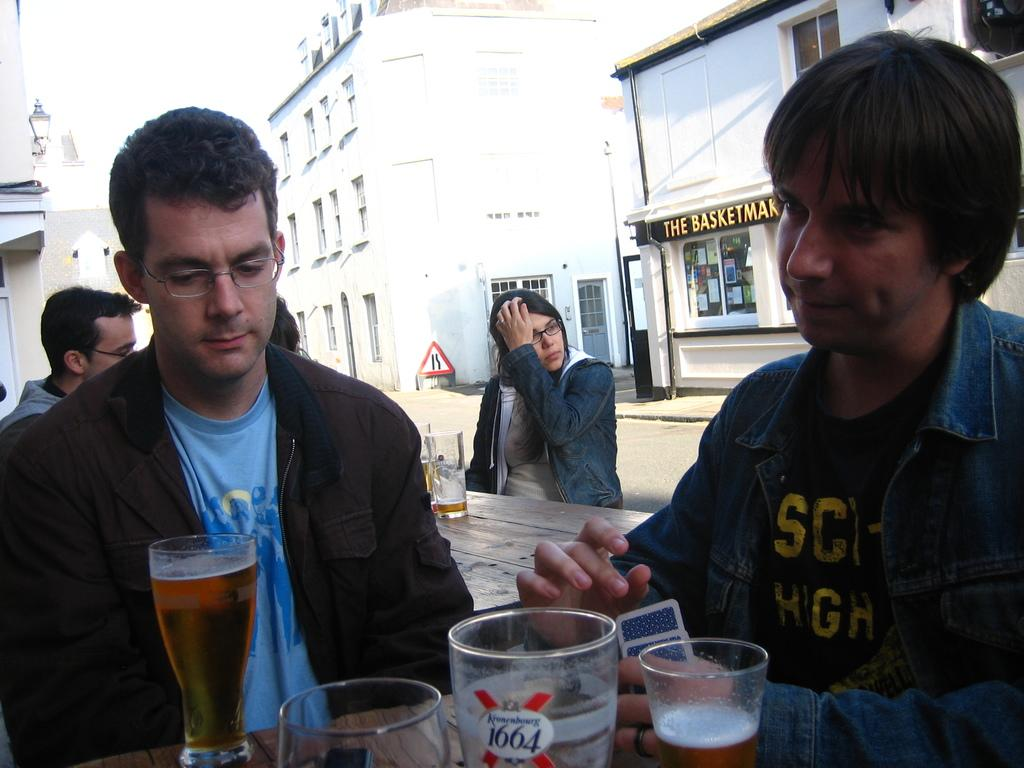What are the people in the image doing? The people in the image are sitting. What objects are present on the tables in the image? There are glasses placed on the tables. What can be seen in the background of the image? There are buildings and the sky visible in the background of the image. Can you see an owl sitting on the table in the image? No, there is no owl present in the image. What is the end of the image? The image does not have an end, as it is a two-dimensional representation. 